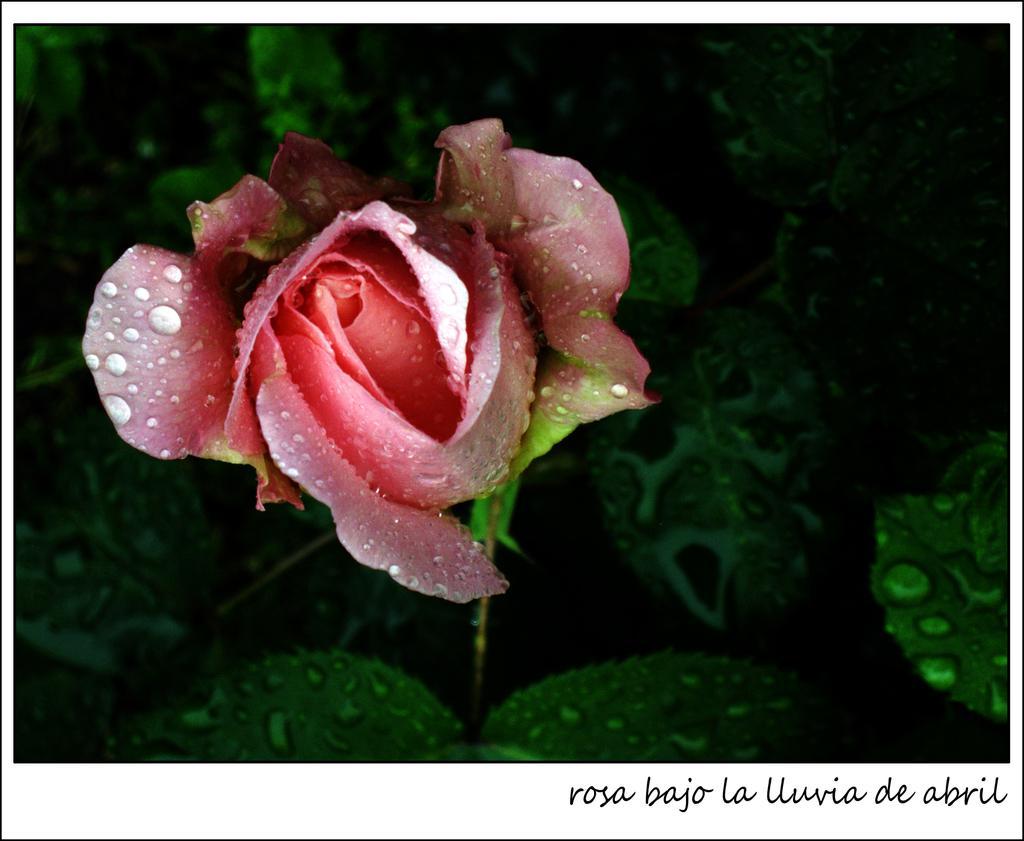Describe this image in one or two sentences. In this image I can see a flower which is pink and red in color to a tree which is green in color. I can see few water drops on the flower and the tree. 